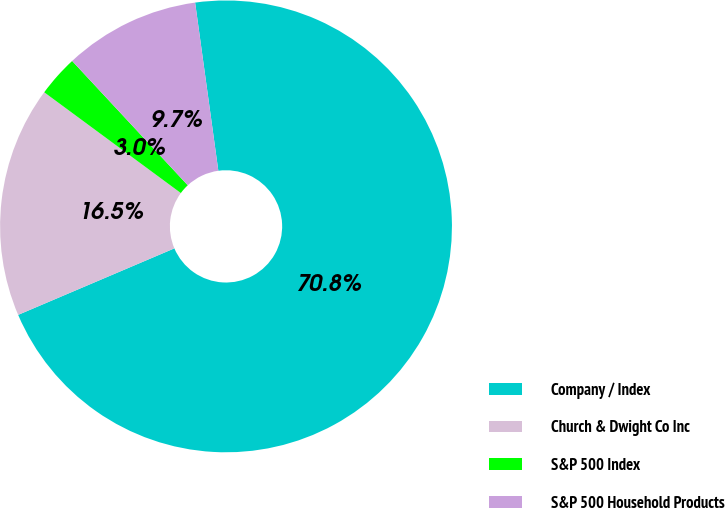Convert chart. <chart><loc_0><loc_0><loc_500><loc_500><pie_chart><fcel>Company / Index<fcel>Church & Dwight Co Inc<fcel>S&P 500 Index<fcel>S&P 500 Household Products<nl><fcel>70.77%<fcel>16.52%<fcel>2.96%<fcel>9.74%<nl></chart> 